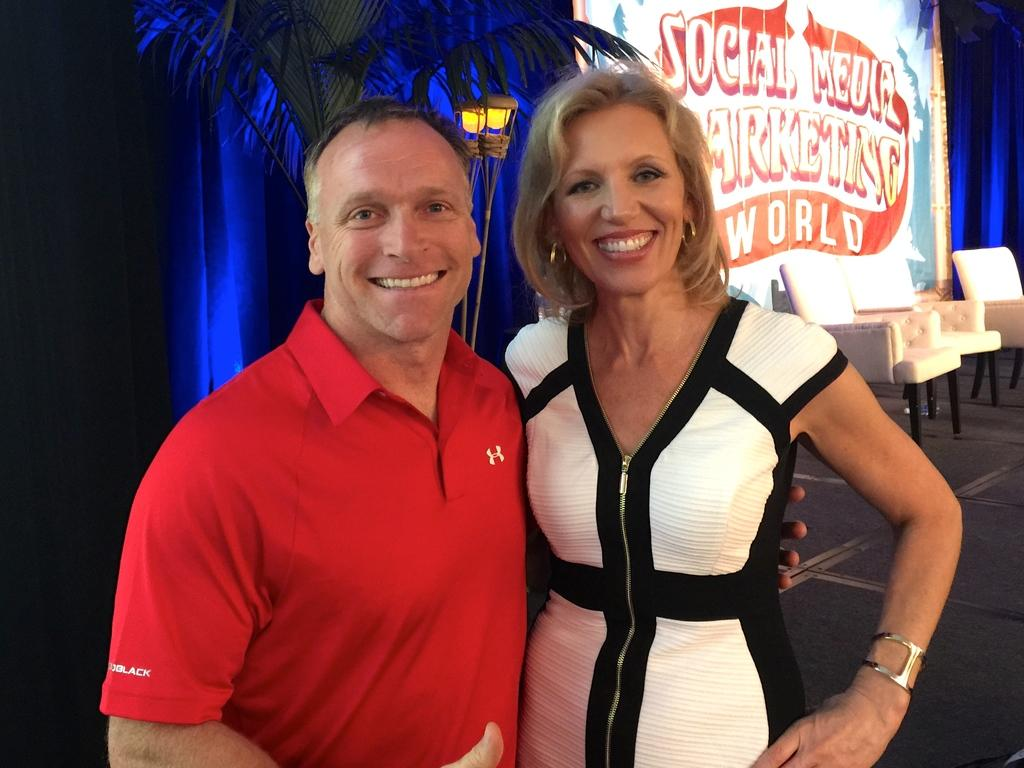<image>
Create a compact narrative representing the image presented. a social media marketing sign behind a couple 